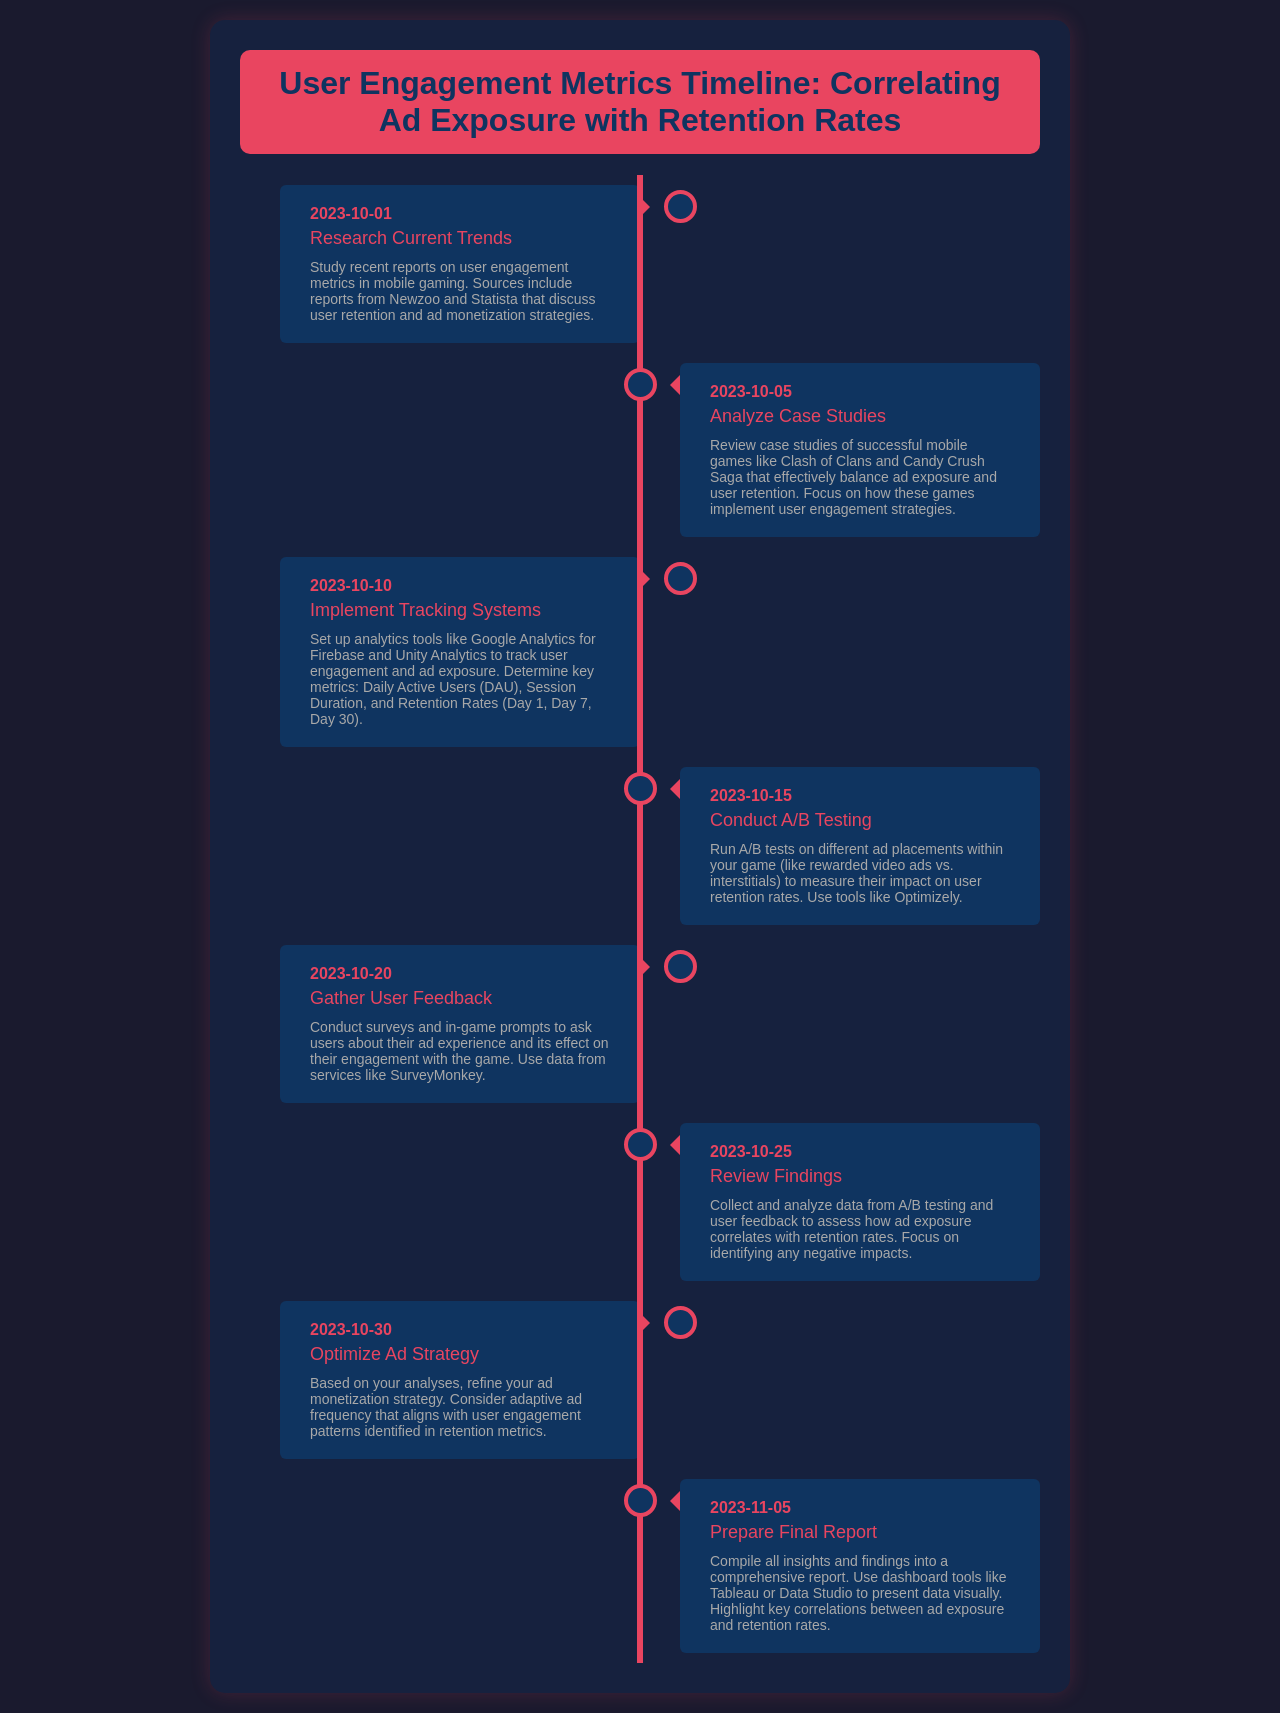What is the first activity listed in the timeline? The first activity listed in the timeline is "Research Current Trends," scheduled for October 1, 2023.
Answer: Research Current Trends What is the date of the A/B Testing phase? The A/B Testing phase occurs on October 15, 2023, according to the timeline.
Answer: October 15, 2023 Which analytics tools are suggested for tracking user engagement? The timeline mentions Google Analytics for Firebase and Unity Analytics for tracking user engagement.
Answer: Google Analytics for Firebase and Unity Analytics What feedback method is proposed to gather user opinions on ad experiences? Surveys and in-game prompts are suggested as methods to gather user opinions about ad experiences.
Answer: Surveys and in-game prompts What is the final activity in the timeline? The final activity in the timeline is "Prepare Final Report" on November 5, 2023.
Answer: Prepare Final Report What is one of the metrics mentioned that will be tracked? The metrics mentioned include Daily Active Users (DAU), Session Duration, and Retention Rates, specifically Day 1, Day 7, and Day 30.
Answer: Daily Active Users (DAU) What is the main focus of the user feedback gathering activity? The main focus is to ask users about their ad experience and its effect on their engagement with the game.
Answer: Ad experience and engagement What is the purpose of the October 25 activity? The purpose of the October 25 activity is to collect and analyze data from A/B testing and user feedback to see how ad exposure correlates with retention rates.
Answer: Analyze data from A/B testing and user feedback 